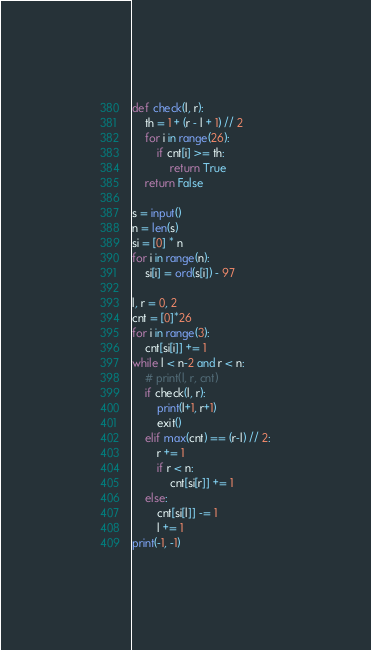<code> <loc_0><loc_0><loc_500><loc_500><_Python_>def check(l, r):
    th = 1 + (r - l + 1) // 2 
    for i in range(26):
        if cnt[i] >= th:
            return True
    return False

s = input()
n = len(s)
si = [0] * n
for i in range(n):
    si[i] = ord(s[i]) - 97

l, r = 0, 2
cnt = [0]*26
for i in range(3):
    cnt[si[i]] += 1
while l < n-2 and r < n:
    # print(l, r, cnt)
    if check(l, r):
        print(l+1, r+1)
        exit()
    elif max(cnt) == (r-l) // 2:
        r += 1
        if r < n:
            cnt[si[r]] += 1
    else:
        cnt[si[l]] -= 1
        l += 1     
print(-1, -1)</code> 